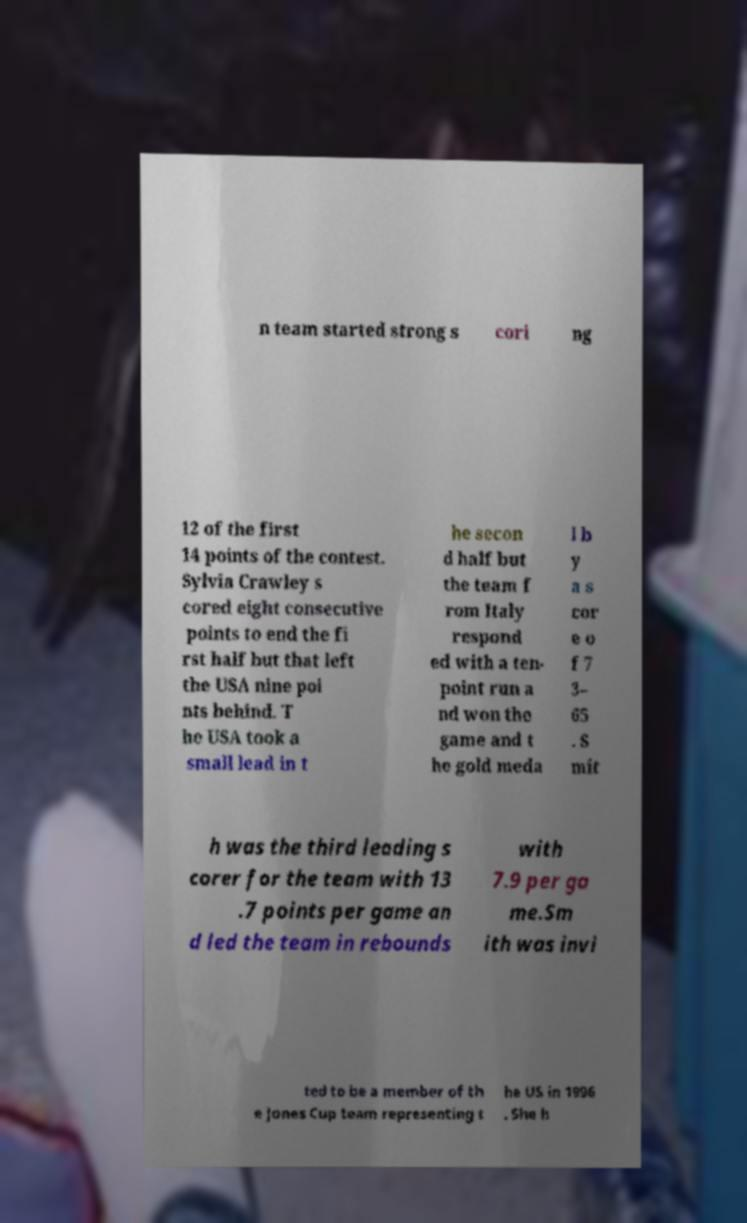I need the written content from this picture converted into text. Can you do that? n team started strong s cori ng 12 of the first 14 points of the contest. Sylvia Crawley s cored eight consecutive points to end the fi rst half but that left the USA nine poi nts behind. T he USA took a small lead in t he secon d half but the team f rom Italy respond ed with a ten- point run a nd won the game and t he gold meda l b y a s cor e o f 7 3– 65 . S mit h was the third leading s corer for the team with 13 .7 points per game an d led the team in rebounds with 7.9 per ga me.Sm ith was invi ted to be a member of th e Jones Cup team representing t he US in 1996 . She h 